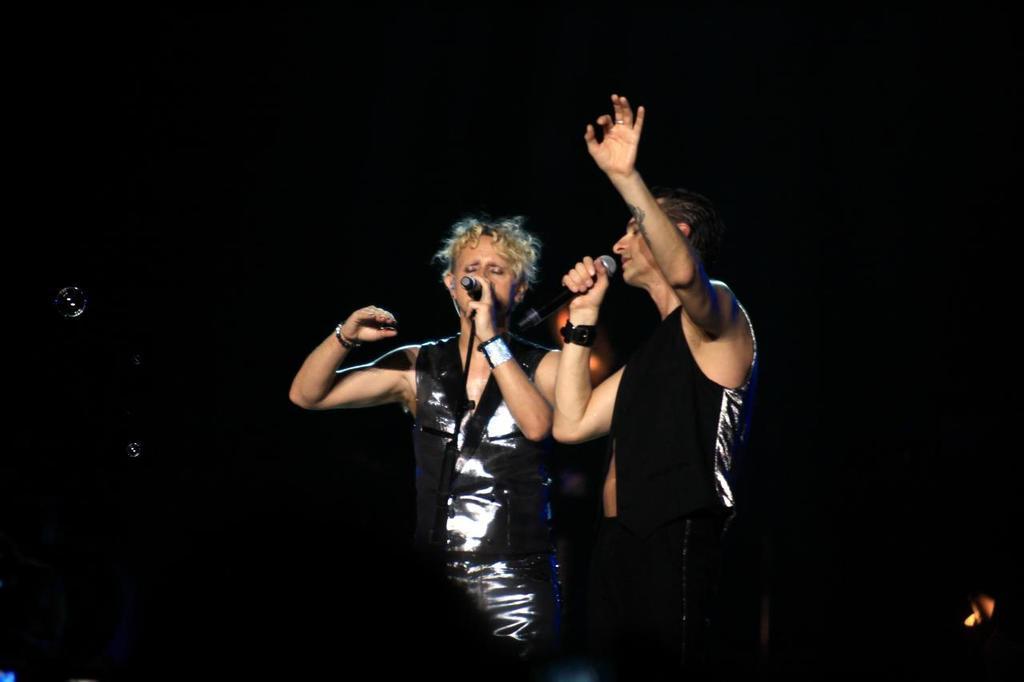Please provide a concise description of this image. In the center of this picture we can see the two persons wearing black color dresses, holding microphones, standing and seems to be singing. The background of the image is very dark. 